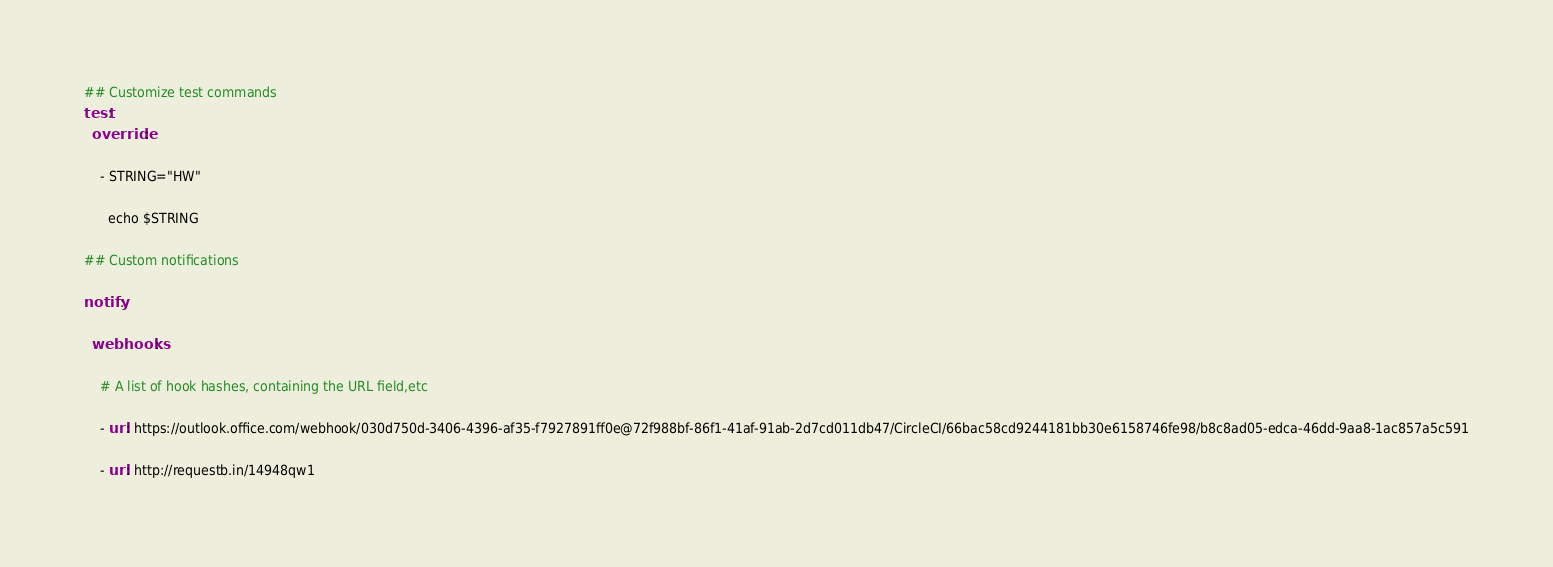<code> <loc_0><loc_0><loc_500><loc_500><_YAML_>## Customize test commands
test:
  override:

    - STRING="HW"

      echo $STRING
      
## Custom notifications

notify:

  webhooks:

    # A list of hook hashes, containing the URL field,etc

    - url: https://outlook.office.com/webhook/030d750d-3406-4396-af35-f7927891ff0e@72f988bf-86f1-41af-91ab-2d7cd011db47/CircleCI/66bac58cd9244181bb30e6158746fe98/b8c8ad05-edca-46dd-9aa8-1ac857a5c591

    - url: http://requestb.in/14948qw1
</code> 